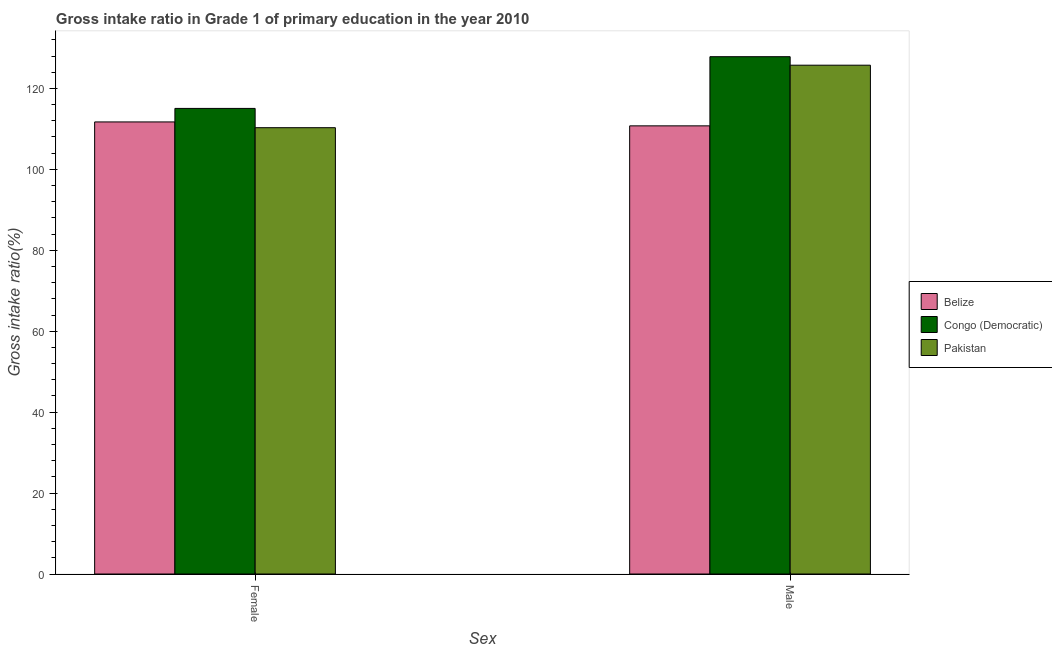How many groups of bars are there?
Offer a very short reply. 2. Are the number of bars per tick equal to the number of legend labels?
Offer a terse response. Yes. Are the number of bars on each tick of the X-axis equal?
Give a very brief answer. Yes. How many bars are there on the 2nd tick from the right?
Ensure brevity in your answer.  3. What is the gross intake ratio(male) in Belize?
Your answer should be compact. 110.75. Across all countries, what is the maximum gross intake ratio(male)?
Your response must be concise. 127.85. Across all countries, what is the minimum gross intake ratio(male)?
Ensure brevity in your answer.  110.75. In which country was the gross intake ratio(female) maximum?
Your answer should be very brief. Congo (Democratic). What is the total gross intake ratio(female) in the graph?
Your answer should be compact. 337.08. What is the difference between the gross intake ratio(female) in Congo (Democratic) and that in Pakistan?
Your response must be concise. 4.76. What is the difference between the gross intake ratio(male) in Belize and the gross intake ratio(female) in Congo (Democratic)?
Provide a short and direct response. -4.31. What is the average gross intake ratio(male) per country?
Provide a succinct answer. 121.45. What is the difference between the gross intake ratio(female) and gross intake ratio(male) in Belize?
Offer a very short reply. 0.97. What is the ratio of the gross intake ratio(female) in Congo (Democratic) to that in Pakistan?
Offer a very short reply. 1.04. Is the gross intake ratio(male) in Congo (Democratic) less than that in Belize?
Provide a short and direct response. No. What does the 3rd bar from the left in Female represents?
Keep it short and to the point. Pakistan. What does the 1st bar from the right in Male represents?
Ensure brevity in your answer.  Pakistan. How many bars are there?
Keep it short and to the point. 6. Does the graph contain any zero values?
Your response must be concise. No. Does the graph contain grids?
Offer a terse response. No. Where does the legend appear in the graph?
Your response must be concise. Center right. How are the legend labels stacked?
Provide a short and direct response. Vertical. What is the title of the graph?
Give a very brief answer. Gross intake ratio in Grade 1 of primary education in the year 2010. Does "Lesotho" appear as one of the legend labels in the graph?
Your response must be concise. No. What is the label or title of the X-axis?
Offer a very short reply. Sex. What is the label or title of the Y-axis?
Ensure brevity in your answer.  Gross intake ratio(%). What is the Gross intake ratio(%) in Belize in Female?
Give a very brief answer. 111.72. What is the Gross intake ratio(%) in Congo (Democratic) in Female?
Your answer should be compact. 115.06. What is the Gross intake ratio(%) in Pakistan in Female?
Ensure brevity in your answer.  110.3. What is the Gross intake ratio(%) in Belize in Male?
Your answer should be compact. 110.75. What is the Gross intake ratio(%) in Congo (Democratic) in Male?
Make the answer very short. 127.85. What is the Gross intake ratio(%) of Pakistan in Male?
Your answer should be compact. 125.74. Across all Sex, what is the maximum Gross intake ratio(%) of Belize?
Keep it short and to the point. 111.72. Across all Sex, what is the maximum Gross intake ratio(%) of Congo (Democratic)?
Your response must be concise. 127.85. Across all Sex, what is the maximum Gross intake ratio(%) of Pakistan?
Provide a short and direct response. 125.74. Across all Sex, what is the minimum Gross intake ratio(%) in Belize?
Provide a succinct answer. 110.75. Across all Sex, what is the minimum Gross intake ratio(%) in Congo (Democratic)?
Make the answer very short. 115.06. Across all Sex, what is the minimum Gross intake ratio(%) of Pakistan?
Ensure brevity in your answer.  110.3. What is the total Gross intake ratio(%) of Belize in the graph?
Give a very brief answer. 222.48. What is the total Gross intake ratio(%) of Congo (Democratic) in the graph?
Give a very brief answer. 242.91. What is the total Gross intake ratio(%) of Pakistan in the graph?
Give a very brief answer. 236.04. What is the difference between the Gross intake ratio(%) of Belize in Female and that in Male?
Provide a succinct answer. 0.97. What is the difference between the Gross intake ratio(%) in Congo (Democratic) in Female and that in Male?
Provide a short and direct response. -12.78. What is the difference between the Gross intake ratio(%) in Pakistan in Female and that in Male?
Your answer should be compact. -15.44. What is the difference between the Gross intake ratio(%) in Belize in Female and the Gross intake ratio(%) in Congo (Democratic) in Male?
Make the answer very short. -16.12. What is the difference between the Gross intake ratio(%) in Belize in Female and the Gross intake ratio(%) in Pakistan in Male?
Your answer should be very brief. -14.02. What is the difference between the Gross intake ratio(%) in Congo (Democratic) in Female and the Gross intake ratio(%) in Pakistan in Male?
Give a very brief answer. -10.68. What is the average Gross intake ratio(%) in Belize per Sex?
Keep it short and to the point. 111.24. What is the average Gross intake ratio(%) of Congo (Democratic) per Sex?
Keep it short and to the point. 121.45. What is the average Gross intake ratio(%) of Pakistan per Sex?
Your answer should be compact. 118.02. What is the difference between the Gross intake ratio(%) in Belize and Gross intake ratio(%) in Congo (Democratic) in Female?
Provide a short and direct response. -3.34. What is the difference between the Gross intake ratio(%) in Belize and Gross intake ratio(%) in Pakistan in Female?
Provide a short and direct response. 1.42. What is the difference between the Gross intake ratio(%) in Congo (Democratic) and Gross intake ratio(%) in Pakistan in Female?
Offer a very short reply. 4.76. What is the difference between the Gross intake ratio(%) of Belize and Gross intake ratio(%) of Congo (Democratic) in Male?
Keep it short and to the point. -17.09. What is the difference between the Gross intake ratio(%) of Belize and Gross intake ratio(%) of Pakistan in Male?
Make the answer very short. -14.99. What is the difference between the Gross intake ratio(%) of Congo (Democratic) and Gross intake ratio(%) of Pakistan in Male?
Your answer should be very brief. 2.1. What is the ratio of the Gross intake ratio(%) in Belize in Female to that in Male?
Your response must be concise. 1.01. What is the ratio of the Gross intake ratio(%) in Congo (Democratic) in Female to that in Male?
Offer a very short reply. 0.9. What is the ratio of the Gross intake ratio(%) of Pakistan in Female to that in Male?
Make the answer very short. 0.88. What is the difference between the highest and the second highest Gross intake ratio(%) in Belize?
Make the answer very short. 0.97. What is the difference between the highest and the second highest Gross intake ratio(%) in Congo (Democratic)?
Provide a succinct answer. 12.78. What is the difference between the highest and the second highest Gross intake ratio(%) in Pakistan?
Keep it short and to the point. 15.44. What is the difference between the highest and the lowest Gross intake ratio(%) of Belize?
Make the answer very short. 0.97. What is the difference between the highest and the lowest Gross intake ratio(%) of Congo (Democratic)?
Give a very brief answer. 12.78. What is the difference between the highest and the lowest Gross intake ratio(%) in Pakistan?
Provide a succinct answer. 15.44. 